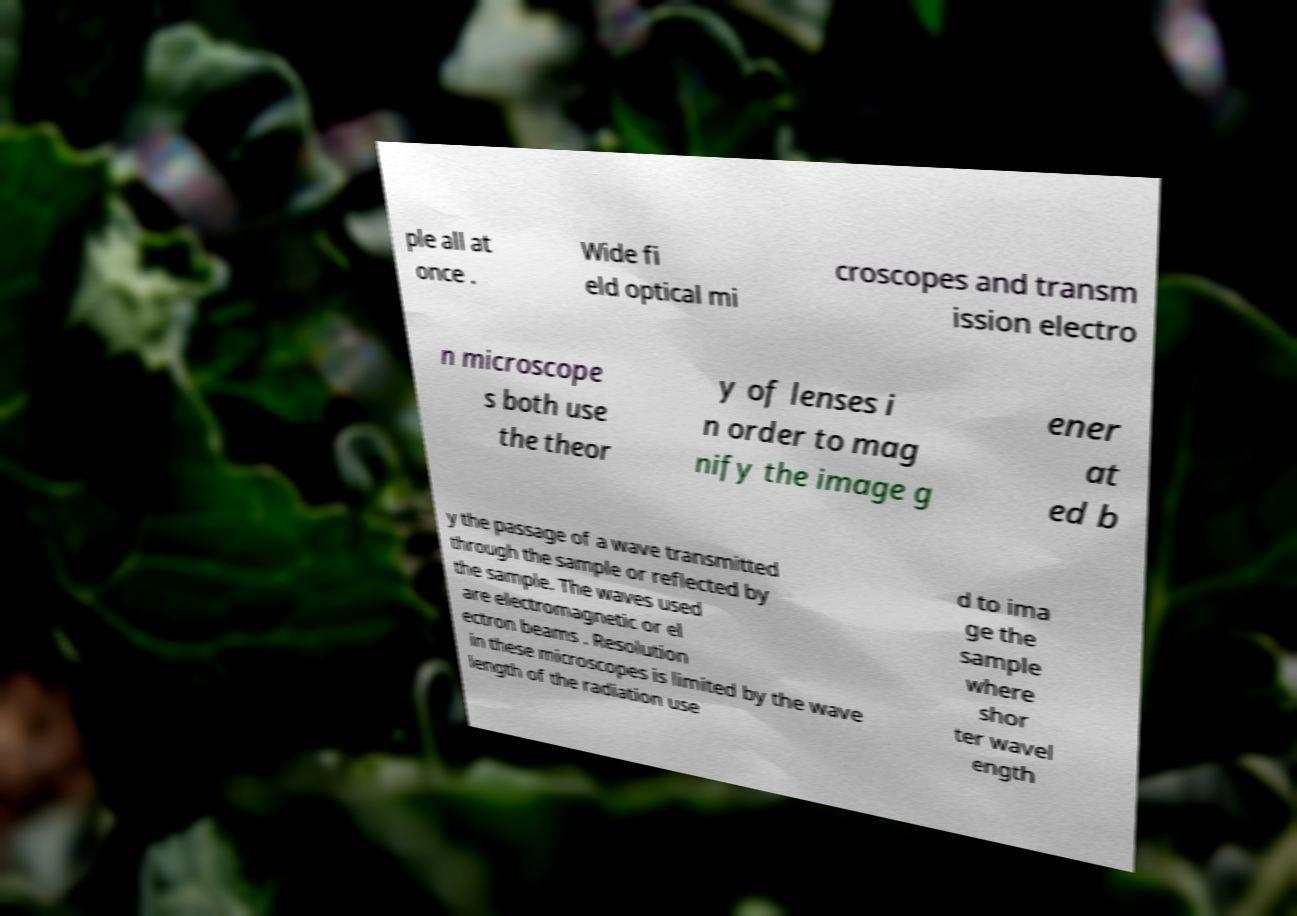Please read and relay the text visible in this image. What does it say? ple all at once . Wide fi eld optical mi croscopes and transm ission electro n microscope s both use the theor y of lenses i n order to mag nify the image g ener at ed b y the passage of a wave transmitted through the sample or reflected by the sample. The waves used are electromagnetic or el ectron beams . Resolution in these microscopes is limited by the wave length of the radiation use d to ima ge the sample where shor ter wavel ength 